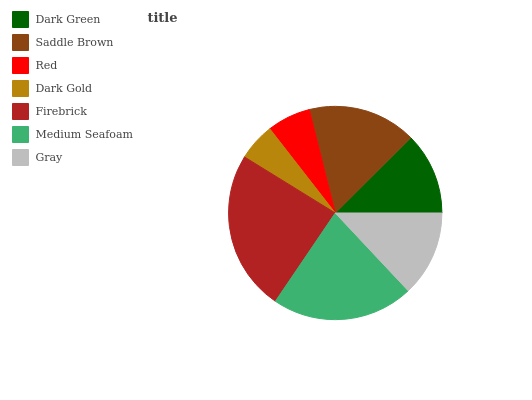Is Dark Gold the minimum?
Answer yes or no. Yes. Is Firebrick the maximum?
Answer yes or no. Yes. Is Saddle Brown the minimum?
Answer yes or no. No. Is Saddle Brown the maximum?
Answer yes or no. No. Is Saddle Brown greater than Dark Green?
Answer yes or no. Yes. Is Dark Green less than Saddle Brown?
Answer yes or no. Yes. Is Dark Green greater than Saddle Brown?
Answer yes or no. No. Is Saddle Brown less than Dark Green?
Answer yes or no. No. Is Gray the high median?
Answer yes or no. Yes. Is Gray the low median?
Answer yes or no. Yes. Is Red the high median?
Answer yes or no. No. Is Dark Gold the low median?
Answer yes or no. No. 